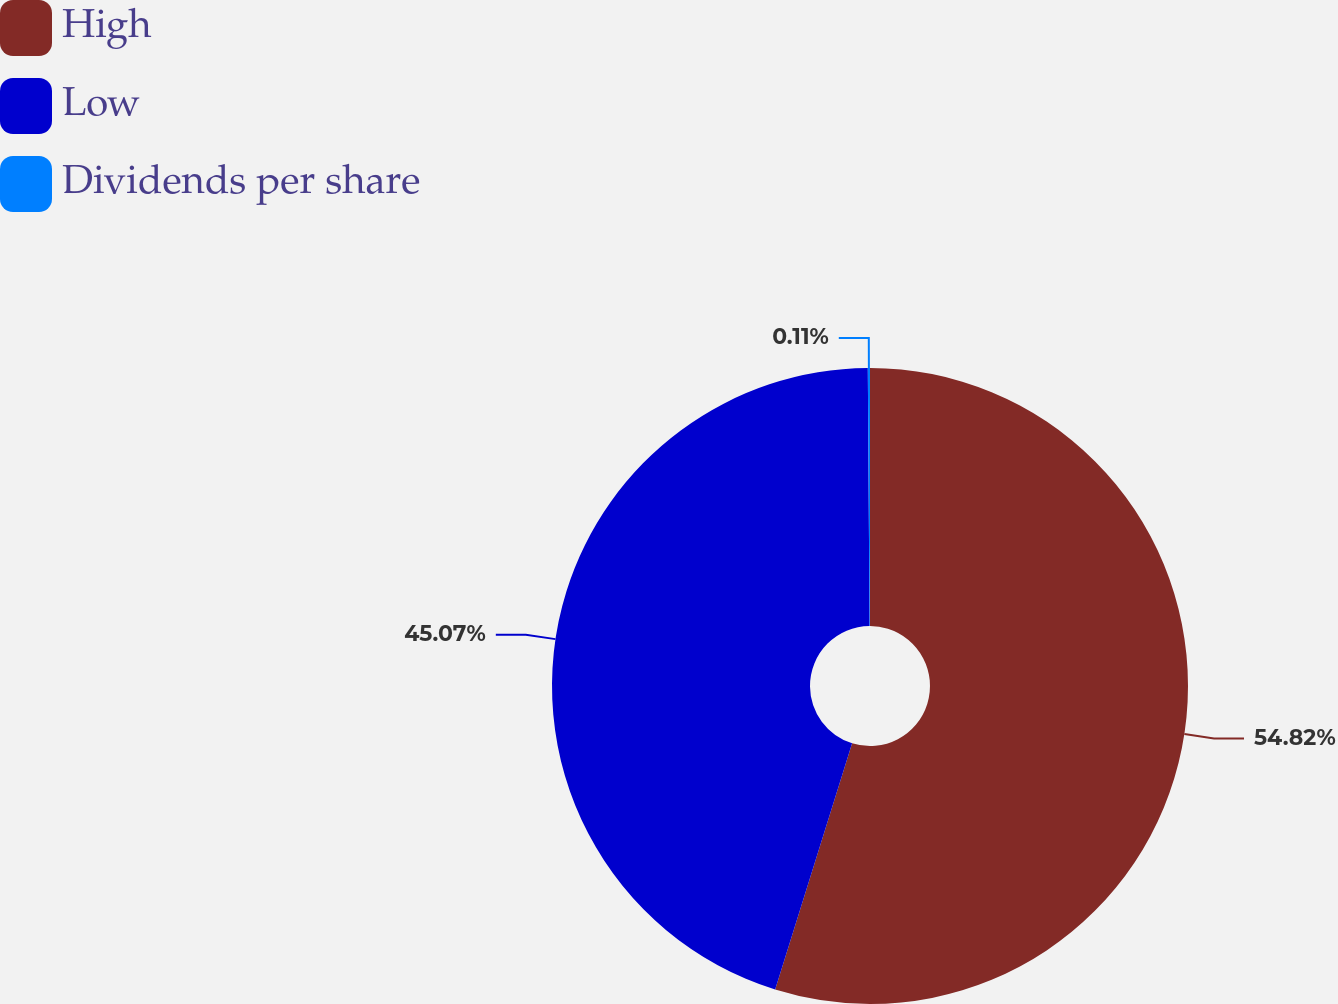Convert chart to OTSL. <chart><loc_0><loc_0><loc_500><loc_500><pie_chart><fcel>High<fcel>Low<fcel>Dividends per share<nl><fcel>54.82%<fcel>45.07%<fcel>0.11%<nl></chart> 